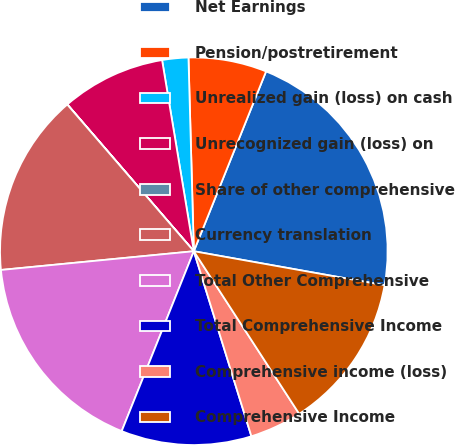<chart> <loc_0><loc_0><loc_500><loc_500><pie_chart><fcel>Net Earnings<fcel>Pension/postretirement<fcel>Unrealized gain (loss) on cash<fcel>Unrecognized gain (loss) on<fcel>Share of other comprehensive<fcel>Currency translation<fcel>Total Other Comprehensive<fcel>Total Comprehensive Income<fcel>Comprehensive income (loss)<fcel>Comprehensive Income<nl><fcel>21.73%<fcel>6.52%<fcel>2.18%<fcel>8.7%<fcel>0.01%<fcel>15.21%<fcel>17.39%<fcel>10.87%<fcel>4.35%<fcel>13.04%<nl></chart> 